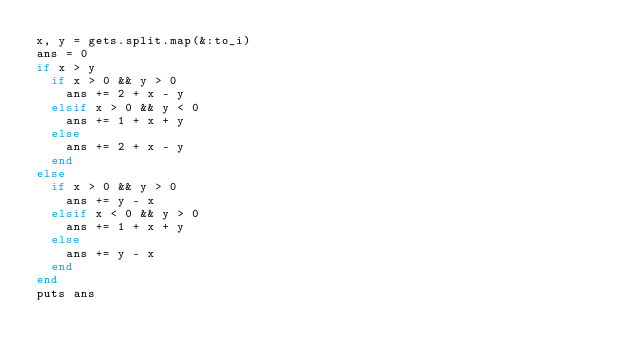<code> <loc_0><loc_0><loc_500><loc_500><_Ruby_>x, y = gets.split.map(&:to_i)
ans = 0
if x > y
  if x > 0 && y > 0
    ans += 2 + x - y
  elsif x > 0 && y < 0
    ans += 1 + x + y
  else
    ans += 2 + x - y
  end
else
  if x > 0 && y > 0
    ans += y - x
  elsif x < 0 && y > 0
    ans += 1 + x + y
  else
    ans += y - x
  end
end
puts ans
</code> 